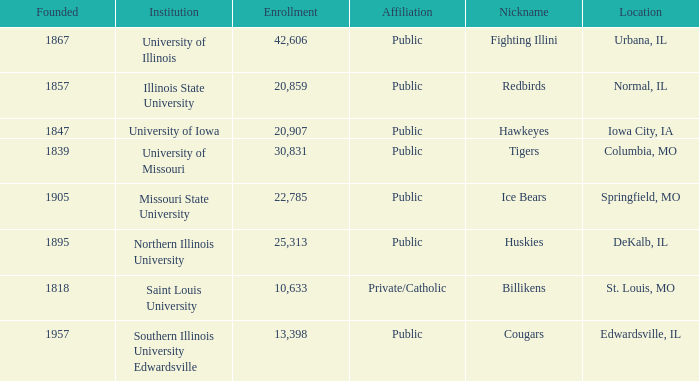What is the average enrollment of the Redbirds' school? 20859.0. 